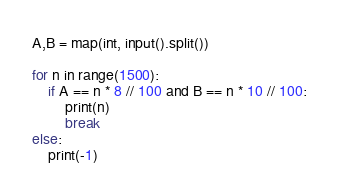<code> <loc_0><loc_0><loc_500><loc_500><_Python_>A,B = map(int, input().split())

for n in range(1500):
    if A == n * 8 // 100 and B == n * 10 // 100:
        print(n)
        break
else:
    print(-1)</code> 